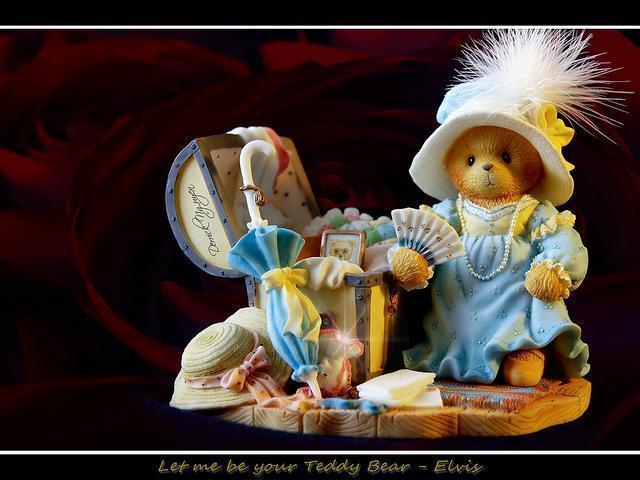How many people are wearing suspenders?
Give a very brief answer. 0. 